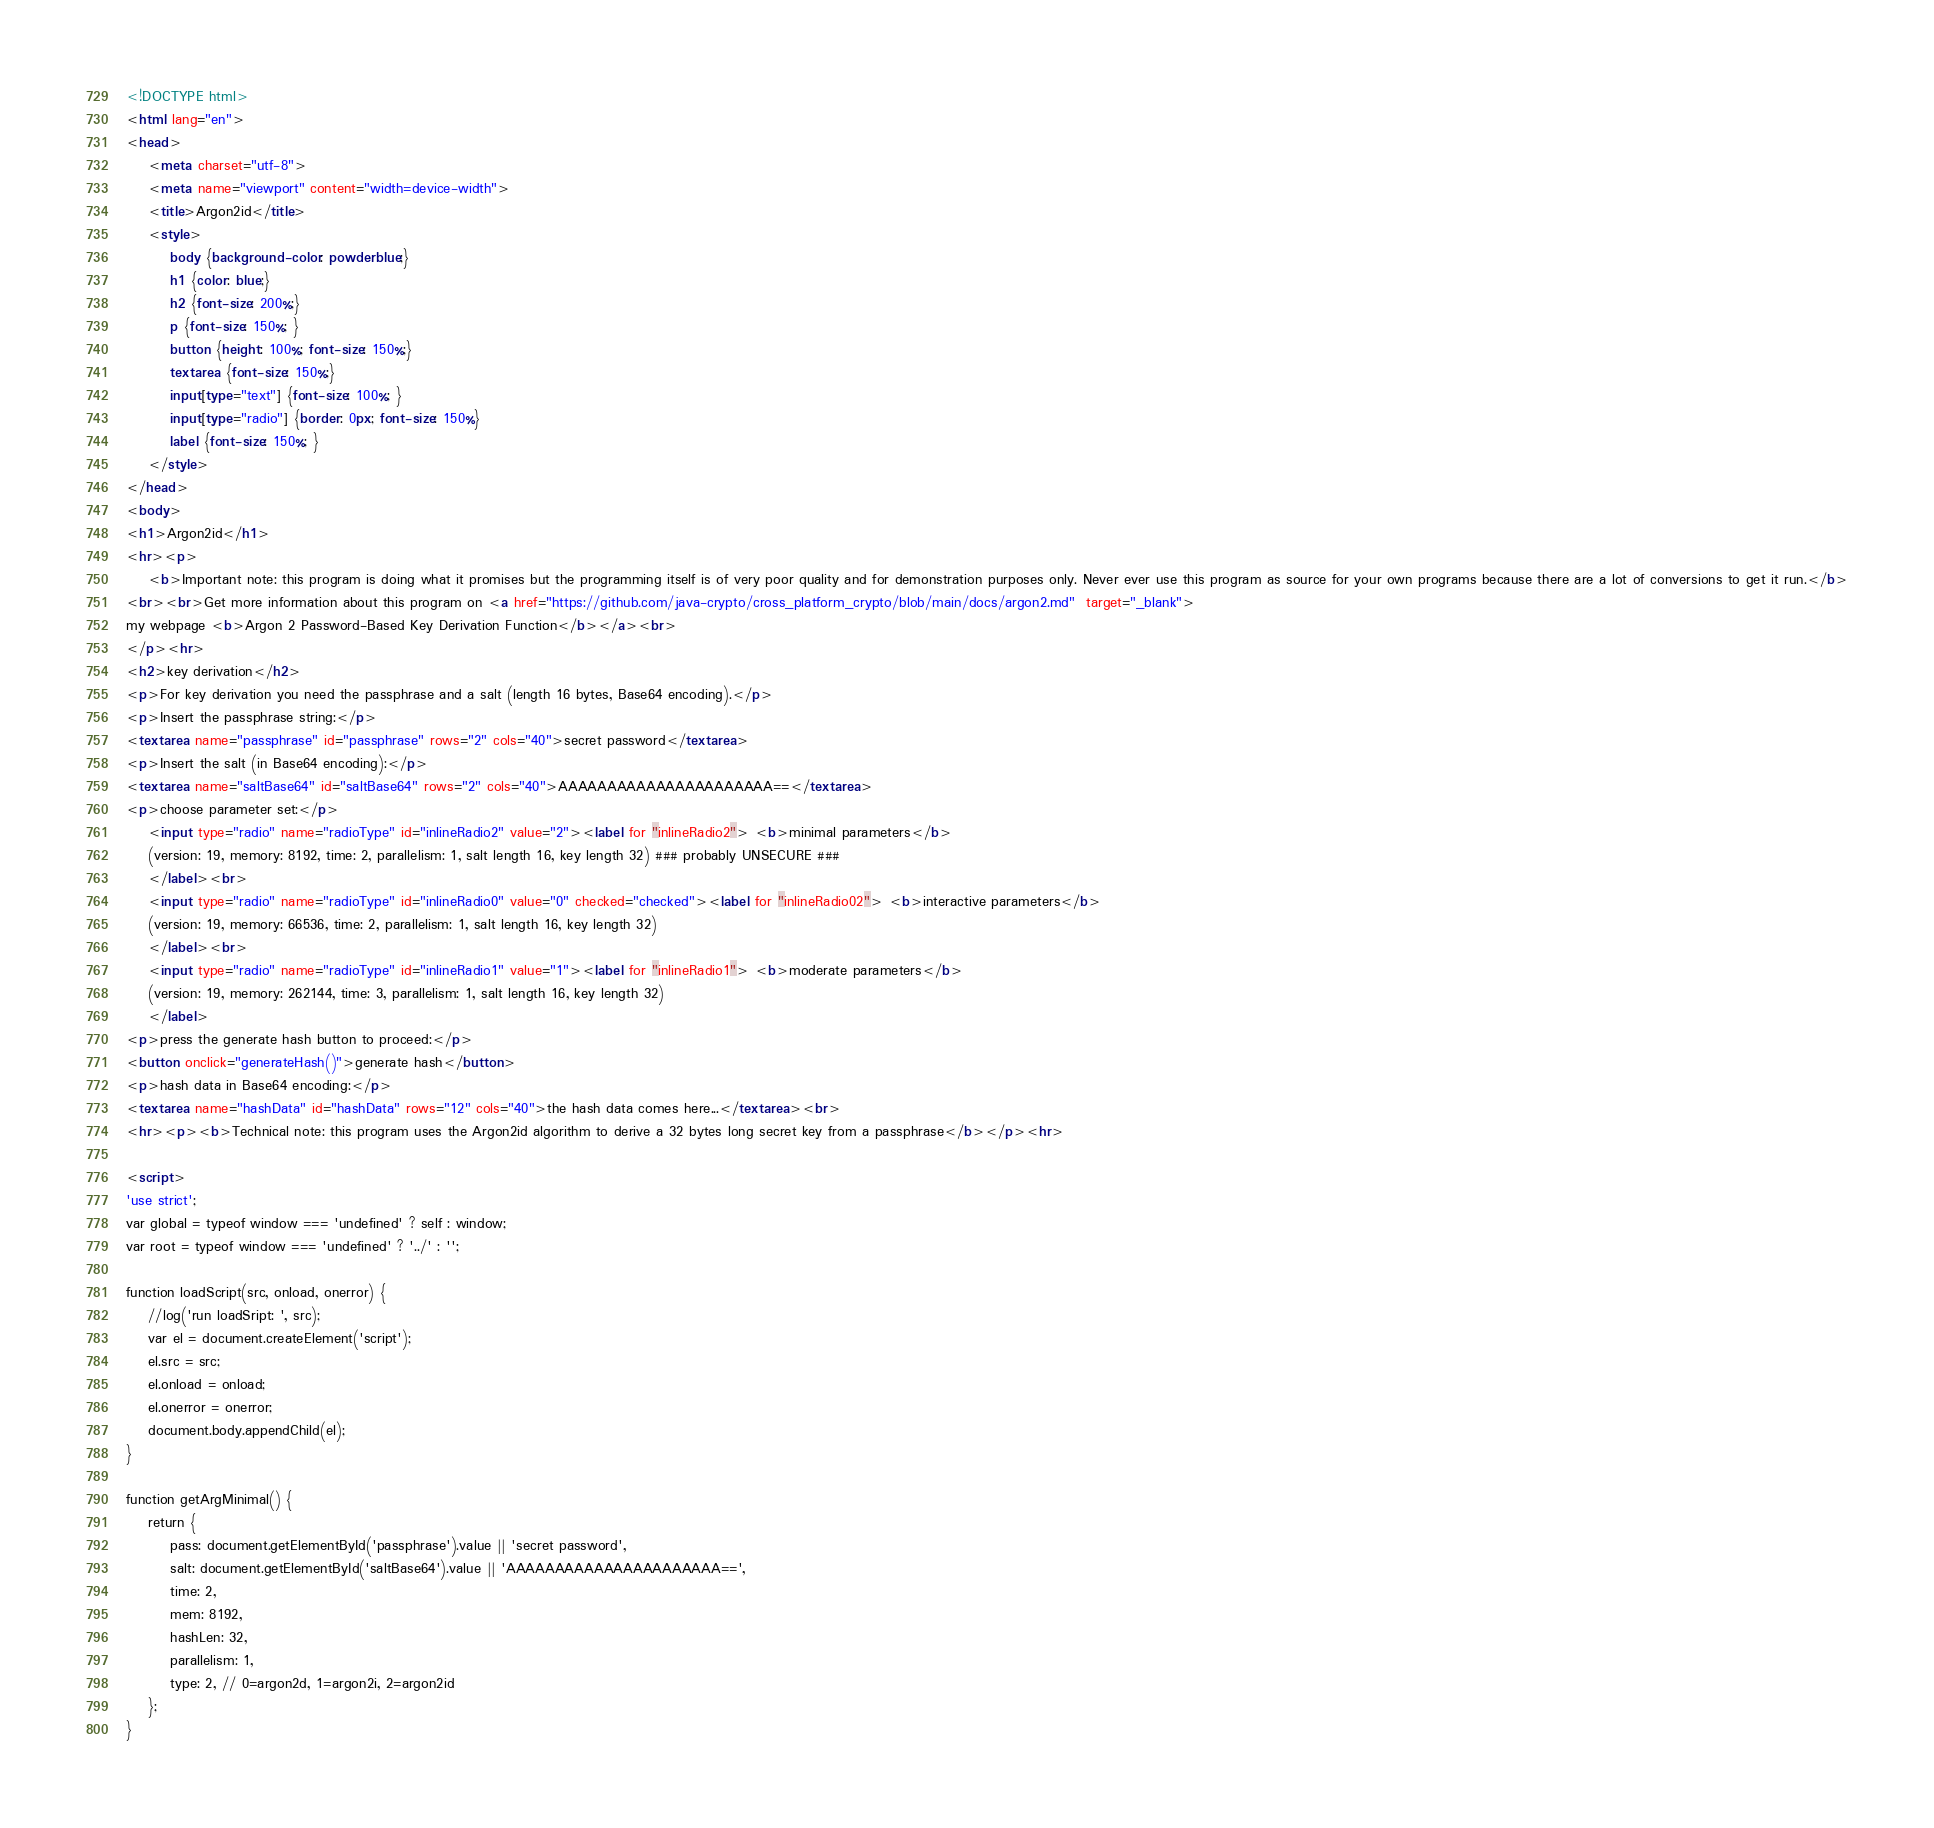<code> <loc_0><loc_0><loc_500><loc_500><_HTML_><!DOCTYPE html>
<html lang="en">
<head>
	<meta charset="utf-8">
	<meta name="viewport" content="width=device-width">
	<title>Argon2id</title>
	<style>
		body {background-color: powderblue;}
		h1 {color: blue;}
		h2 {font-size: 200%;}
		p {font-size: 150%; }
		button {height: 100%; font-size: 150%;}
		textarea {font-size: 150%;}
		input[type="text"] {font-size: 100%; }
		input[type="radio"] {border: 0px; font-size: 150%}
		label {font-size: 150%; }
	</style>		
</head>
<body>
<h1>Argon2id</h1>
<hr><p>
	<b>Important note: this program is doing what it promises but the programming itself is of very poor quality and for demonstration purposes only. Never ever use this program as source for your own programs because there are a lot of conversions to get it run.</b>
<br><br>Get more information about this program on <a href="https://github.com/java-crypto/cross_platform_crypto/blob/main/docs/argon2.md"  target="_blank">
my webpage <b>Argon 2 Password-Based Key Derivation Function</b></a><br>
</p><hr>
<h2>key derivation</h2>
<p>For key derivation you need the passphrase and a salt (length 16 bytes, Base64 encoding).</p>
<p>Insert the passphrase string:</p>
<textarea name="passphrase" id="passphrase" rows="2" cols="40">secret password</textarea>
<p>Insert the salt (in Base64 encoding):</p>
<textarea name="saltBase64" id="saltBase64" rows="2" cols="40">AAAAAAAAAAAAAAAAAAAAAA==</textarea>
<p>choose parameter set:</p>
	<input type="radio" name="radioType" id="inlineRadio2" value="2"><label for "inlineRadio2"> <b>minimal parameters</b> 
	(version: 19, memory: 8192, time: 2, parallelism: 1, salt length 16, key length 32) ### probably UNSECURE ###
	</label><br>
	<input type="radio" name="radioType" id="inlineRadio0" value="0" checked="checked"><label for "inlineRadio02"> <b>interactive parameters</b> 
	(version: 19, memory: 66536, time: 2, parallelism: 1, salt length 16, key length 32)
	</label><br>
	<input type="radio" name="radioType" id="inlineRadio1" value="1"><label for "inlineRadio1"> <b>moderate parameters</b> 
	(version: 19, memory: 262144, time: 3, parallelism: 1, salt length 16, key length 32)
	</label>
<p>press the generate hash button to proceed:</p>
<button onclick="generateHash()">generate hash</button> 
<p>hash data in Base64 encoding:</p>
<textarea name="hashData" id="hashData" rows="12" cols="40">the hash data comes here...</textarea><br>
<hr><p><b>Technical note: this program uses the Argon2id algorithm to derive a 32 bytes long secret key from a passphrase</b></p><hr>

<script>
'use strict';
var global = typeof window === 'undefined' ? self : window;
var root = typeof window === 'undefined' ? '../' : '';

function loadScript(src, onload, onerror) {
	//log('run loadSript: ', src);
    var el = document.createElement('script');
    el.src = src;
    el.onload = onload;
    el.onerror = onerror;
    document.body.appendChild(el);
}

function getArgMinimal() {
    return {
        pass: document.getElementById('passphrase').value || 'secret password',
        salt: document.getElementById('saltBase64').value || 'AAAAAAAAAAAAAAAAAAAAAA==',
		time: 2,
        mem: 8192,
        hashLen: 32,
        parallelism: 1,
        type: 2, // 0=argon2d, 1=argon2i, 2=argon2id
    };
}
</code> 